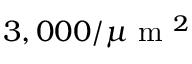Convert formula to latex. <formula><loc_0><loc_0><loc_500><loc_500>3 , 0 0 0 / \mu m ^ { 2 }</formula> 